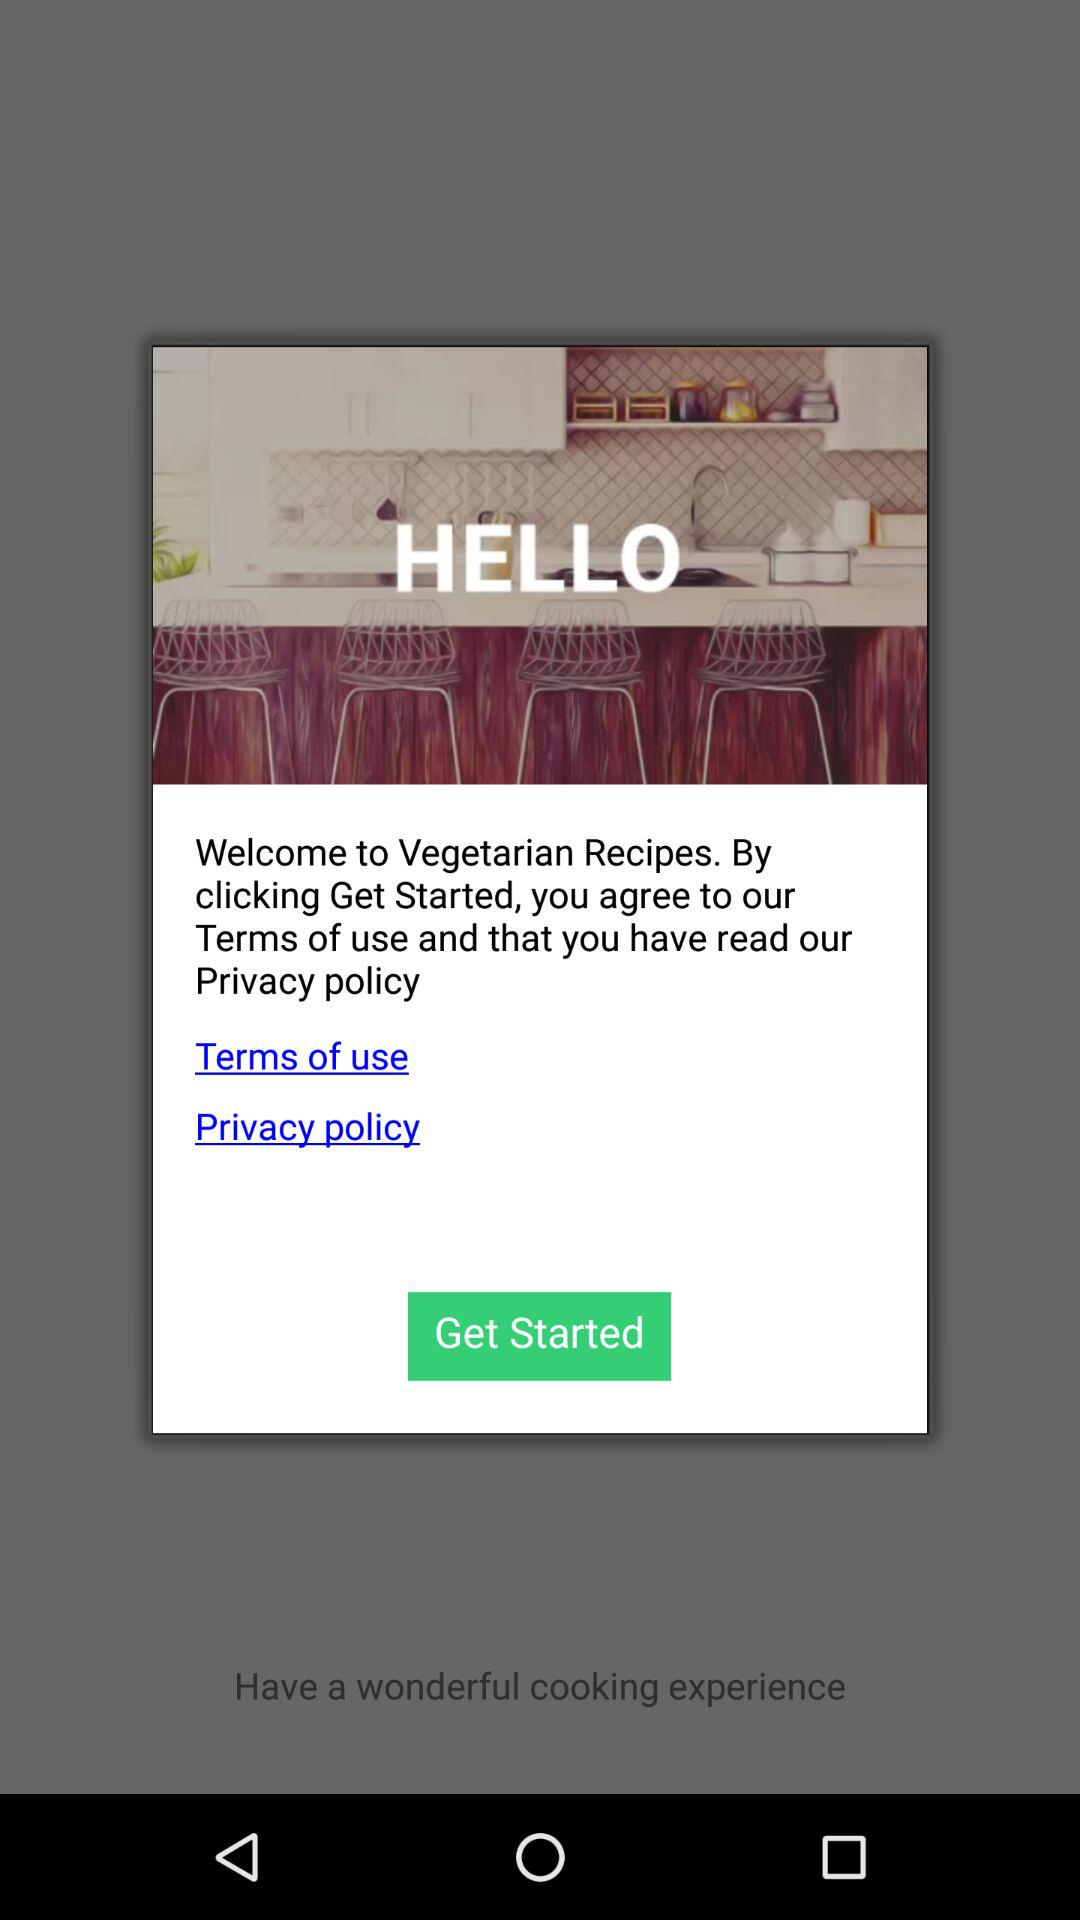What is the name of the application? The name of the application is "Vegetarian Recipes". 